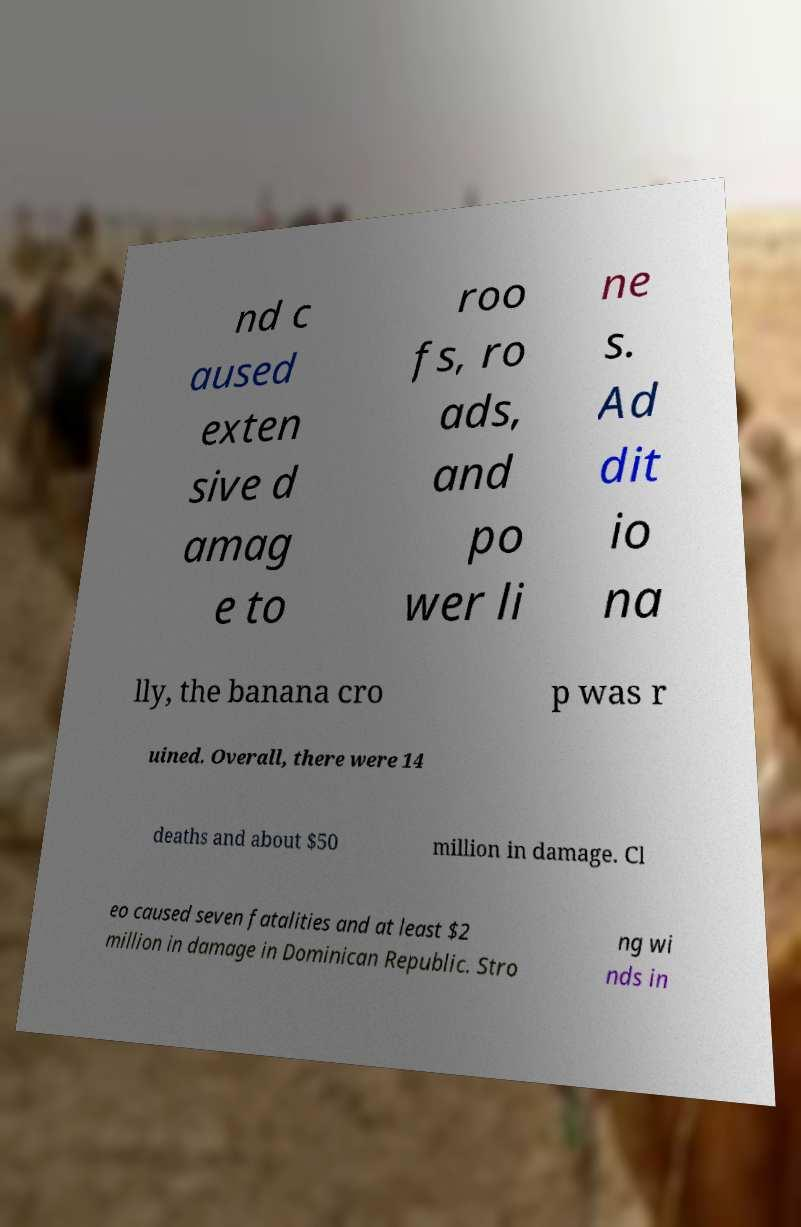I need the written content from this picture converted into text. Can you do that? nd c aused exten sive d amag e to roo fs, ro ads, and po wer li ne s. Ad dit io na lly, the banana cro p was r uined. Overall, there were 14 deaths and about $50 million in damage. Cl eo caused seven fatalities and at least $2 million in damage in Dominican Republic. Stro ng wi nds in 